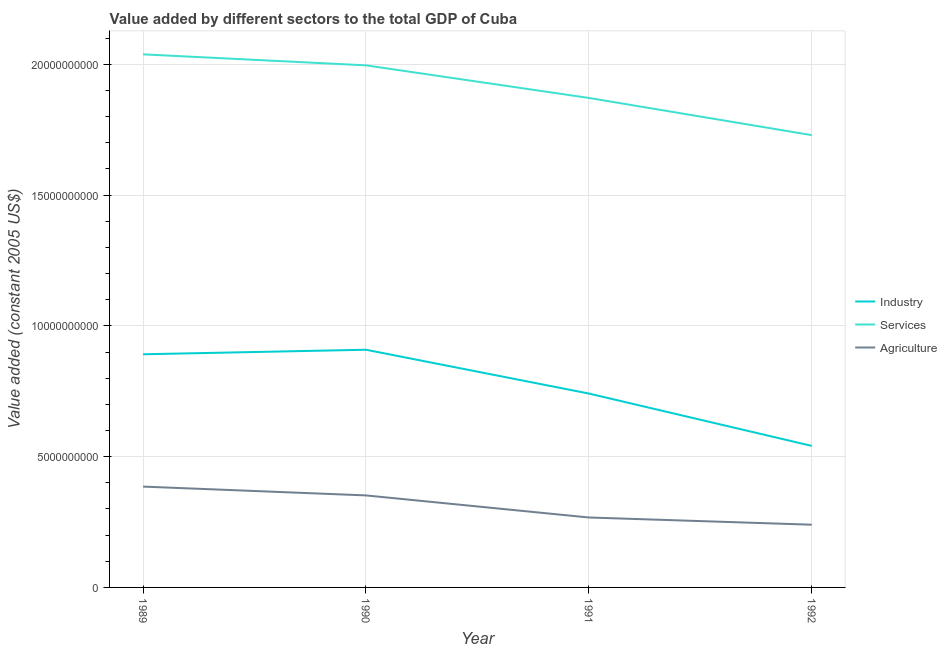What is the value added by agricultural sector in 1992?
Offer a very short reply. 2.40e+09. Across all years, what is the maximum value added by agricultural sector?
Your answer should be compact. 3.85e+09. Across all years, what is the minimum value added by agricultural sector?
Offer a very short reply. 2.40e+09. In which year was the value added by services maximum?
Ensure brevity in your answer.  1989. What is the total value added by agricultural sector in the graph?
Offer a terse response. 1.24e+1. What is the difference between the value added by industrial sector in 1991 and that in 1992?
Provide a short and direct response. 2.00e+09. What is the difference between the value added by industrial sector in 1992 and the value added by services in 1991?
Provide a succinct answer. -1.33e+1. What is the average value added by industrial sector per year?
Give a very brief answer. 7.71e+09. In the year 1991, what is the difference between the value added by services and value added by industrial sector?
Your response must be concise. 1.13e+1. In how many years, is the value added by industrial sector greater than 1000000000 US$?
Give a very brief answer. 4. What is the ratio of the value added by agricultural sector in 1990 to that in 1992?
Provide a short and direct response. 1.47. Is the value added by services in 1989 less than that in 1990?
Ensure brevity in your answer.  No. Is the difference between the value added by services in 1990 and 1991 greater than the difference between the value added by industrial sector in 1990 and 1991?
Offer a terse response. No. What is the difference between the highest and the second highest value added by agricultural sector?
Your answer should be compact. 3.37e+08. What is the difference between the highest and the lowest value added by agricultural sector?
Your answer should be compact. 1.46e+09. Is the sum of the value added by agricultural sector in 1991 and 1992 greater than the maximum value added by industrial sector across all years?
Provide a short and direct response. No. Does the value added by services monotonically increase over the years?
Your answer should be very brief. No. Is the value added by industrial sector strictly less than the value added by agricultural sector over the years?
Offer a terse response. No. What is the difference between two consecutive major ticks on the Y-axis?
Offer a terse response. 5.00e+09. Does the graph contain grids?
Make the answer very short. Yes. Where does the legend appear in the graph?
Make the answer very short. Center right. How many legend labels are there?
Provide a short and direct response. 3. How are the legend labels stacked?
Provide a short and direct response. Vertical. What is the title of the graph?
Give a very brief answer. Value added by different sectors to the total GDP of Cuba. Does "Food" appear as one of the legend labels in the graph?
Ensure brevity in your answer.  No. What is the label or title of the Y-axis?
Provide a succinct answer. Value added (constant 2005 US$). What is the Value added (constant 2005 US$) in Industry in 1989?
Your answer should be compact. 8.91e+09. What is the Value added (constant 2005 US$) of Services in 1989?
Your answer should be compact. 2.04e+1. What is the Value added (constant 2005 US$) in Agriculture in 1989?
Provide a succinct answer. 3.85e+09. What is the Value added (constant 2005 US$) in Industry in 1990?
Give a very brief answer. 9.09e+09. What is the Value added (constant 2005 US$) in Services in 1990?
Keep it short and to the point. 2.00e+1. What is the Value added (constant 2005 US$) of Agriculture in 1990?
Make the answer very short. 3.52e+09. What is the Value added (constant 2005 US$) of Industry in 1991?
Ensure brevity in your answer.  7.41e+09. What is the Value added (constant 2005 US$) of Services in 1991?
Make the answer very short. 1.87e+1. What is the Value added (constant 2005 US$) of Agriculture in 1991?
Your response must be concise. 2.67e+09. What is the Value added (constant 2005 US$) in Industry in 1992?
Your answer should be very brief. 5.41e+09. What is the Value added (constant 2005 US$) of Services in 1992?
Give a very brief answer. 1.73e+1. What is the Value added (constant 2005 US$) in Agriculture in 1992?
Ensure brevity in your answer.  2.40e+09. Across all years, what is the maximum Value added (constant 2005 US$) in Industry?
Give a very brief answer. 9.09e+09. Across all years, what is the maximum Value added (constant 2005 US$) of Services?
Offer a very short reply. 2.04e+1. Across all years, what is the maximum Value added (constant 2005 US$) of Agriculture?
Your answer should be very brief. 3.85e+09. Across all years, what is the minimum Value added (constant 2005 US$) of Industry?
Offer a very short reply. 5.41e+09. Across all years, what is the minimum Value added (constant 2005 US$) in Services?
Give a very brief answer. 1.73e+1. Across all years, what is the minimum Value added (constant 2005 US$) of Agriculture?
Ensure brevity in your answer.  2.40e+09. What is the total Value added (constant 2005 US$) of Industry in the graph?
Your response must be concise. 3.08e+1. What is the total Value added (constant 2005 US$) of Services in the graph?
Make the answer very short. 7.63e+1. What is the total Value added (constant 2005 US$) of Agriculture in the graph?
Your answer should be compact. 1.24e+1. What is the difference between the Value added (constant 2005 US$) of Industry in 1989 and that in 1990?
Keep it short and to the point. -1.73e+08. What is the difference between the Value added (constant 2005 US$) of Services in 1989 and that in 1990?
Keep it short and to the point. 4.21e+08. What is the difference between the Value added (constant 2005 US$) of Agriculture in 1989 and that in 1990?
Make the answer very short. 3.37e+08. What is the difference between the Value added (constant 2005 US$) in Industry in 1989 and that in 1991?
Your response must be concise. 1.50e+09. What is the difference between the Value added (constant 2005 US$) of Services in 1989 and that in 1991?
Provide a succinct answer. 1.67e+09. What is the difference between the Value added (constant 2005 US$) of Agriculture in 1989 and that in 1991?
Offer a terse response. 1.18e+09. What is the difference between the Value added (constant 2005 US$) of Industry in 1989 and that in 1992?
Make the answer very short. 3.50e+09. What is the difference between the Value added (constant 2005 US$) in Services in 1989 and that in 1992?
Provide a succinct answer. 3.09e+09. What is the difference between the Value added (constant 2005 US$) of Agriculture in 1989 and that in 1992?
Provide a short and direct response. 1.46e+09. What is the difference between the Value added (constant 2005 US$) of Industry in 1990 and that in 1991?
Your answer should be very brief. 1.67e+09. What is the difference between the Value added (constant 2005 US$) of Services in 1990 and that in 1991?
Provide a short and direct response. 1.25e+09. What is the difference between the Value added (constant 2005 US$) of Agriculture in 1990 and that in 1991?
Provide a short and direct response. 8.44e+08. What is the difference between the Value added (constant 2005 US$) in Industry in 1990 and that in 1992?
Give a very brief answer. 3.68e+09. What is the difference between the Value added (constant 2005 US$) in Services in 1990 and that in 1992?
Ensure brevity in your answer.  2.67e+09. What is the difference between the Value added (constant 2005 US$) in Agriculture in 1990 and that in 1992?
Your answer should be very brief. 1.12e+09. What is the difference between the Value added (constant 2005 US$) in Industry in 1991 and that in 1992?
Provide a short and direct response. 2.00e+09. What is the difference between the Value added (constant 2005 US$) of Services in 1991 and that in 1992?
Make the answer very short. 1.42e+09. What is the difference between the Value added (constant 2005 US$) in Agriculture in 1991 and that in 1992?
Provide a succinct answer. 2.76e+08. What is the difference between the Value added (constant 2005 US$) in Industry in 1989 and the Value added (constant 2005 US$) in Services in 1990?
Ensure brevity in your answer.  -1.10e+1. What is the difference between the Value added (constant 2005 US$) in Industry in 1989 and the Value added (constant 2005 US$) in Agriculture in 1990?
Ensure brevity in your answer.  5.40e+09. What is the difference between the Value added (constant 2005 US$) in Services in 1989 and the Value added (constant 2005 US$) in Agriculture in 1990?
Give a very brief answer. 1.69e+1. What is the difference between the Value added (constant 2005 US$) in Industry in 1989 and the Value added (constant 2005 US$) in Services in 1991?
Keep it short and to the point. -9.80e+09. What is the difference between the Value added (constant 2005 US$) of Industry in 1989 and the Value added (constant 2005 US$) of Agriculture in 1991?
Offer a very short reply. 6.24e+09. What is the difference between the Value added (constant 2005 US$) of Services in 1989 and the Value added (constant 2005 US$) of Agriculture in 1991?
Offer a terse response. 1.77e+1. What is the difference between the Value added (constant 2005 US$) of Industry in 1989 and the Value added (constant 2005 US$) of Services in 1992?
Your answer should be compact. -8.38e+09. What is the difference between the Value added (constant 2005 US$) in Industry in 1989 and the Value added (constant 2005 US$) in Agriculture in 1992?
Your answer should be very brief. 6.52e+09. What is the difference between the Value added (constant 2005 US$) of Services in 1989 and the Value added (constant 2005 US$) of Agriculture in 1992?
Keep it short and to the point. 1.80e+1. What is the difference between the Value added (constant 2005 US$) in Industry in 1990 and the Value added (constant 2005 US$) in Services in 1991?
Offer a very short reply. -9.63e+09. What is the difference between the Value added (constant 2005 US$) of Industry in 1990 and the Value added (constant 2005 US$) of Agriculture in 1991?
Keep it short and to the point. 6.41e+09. What is the difference between the Value added (constant 2005 US$) in Services in 1990 and the Value added (constant 2005 US$) in Agriculture in 1991?
Provide a succinct answer. 1.73e+1. What is the difference between the Value added (constant 2005 US$) in Industry in 1990 and the Value added (constant 2005 US$) in Services in 1992?
Provide a short and direct response. -8.20e+09. What is the difference between the Value added (constant 2005 US$) of Industry in 1990 and the Value added (constant 2005 US$) of Agriculture in 1992?
Your answer should be very brief. 6.69e+09. What is the difference between the Value added (constant 2005 US$) in Services in 1990 and the Value added (constant 2005 US$) in Agriculture in 1992?
Your answer should be compact. 1.76e+1. What is the difference between the Value added (constant 2005 US$) in Industry in 1991 and the Value added (constant 2005 US$) in Services in 1992?
Provide a succinct answer. -9.88e+09. What is the difference between the Value added (constant 2005 US$) of Industry in 1991 and the Value added (constant 2005 US$) of Agriculture in 1992?
Provide a short and direct response. 5.01e+09. What is the difference between the Value added (constant 2005 US$) in Services in 1991 and the Value added (constant 2005 US$) in Agriculture in 1992?
Your answer should be very brief. 1.63e+1. What is the average Value added (constant 2005 US$) in Industry per year?
Provide a short and direct response. 7.71e+09. What is the average Value added (constant 2005 US$) in Services per year?
Make the answer very short. 1.91e+1. What is the average Value added (constant 2005 US$) in Agriculture per year?
Ensure brevity in your answer.  3.11e+09. In the year 1989, what is the difference between the Value added (constant 2005 US$) of Industry and Value added (constant 2005 US$) of Services?
Keep it short and to the point. -1.15e+1. In the year 1989, what is the difference between the Value added (constant 2005 US$) in Industry and Value added (constant 2005 US$) in Agriculture?
Provide a short and direct response. 5.06e+09. In the year 1989, what is the difference between the Value added (constant 2005 US$) of Services and Value added (constant 2005 US$) of Agriculture?
Your answer should be very brief. 1.65e+1. In the year 1990, what is the difference between the Value added (constant 2005 US$) of Industry and Value added (constant 2005 US$) of Services?
Make the answer very short. -1.09e+1. In the year 1990, what is the difference between the Value added (constant 2005 US$) of Industry and Value added (constant 2005 US$) of Agriculture?
Keep it short and to the point. 5.57e+09. In the year 1990, what is the difference between the Value added (constant 2005 US$) of Services and Value added (constant 2005 US$) of Agriculture?
Offer a very short reply. 1.64e+1. In the year 1991, what is the difference between the Value added (constant 2005 US$) in Industry and Value added (constant 2005 US$) in Services?
Your answer should be compact. -1.13e+1. In the year 1991, what is the difference between the Value added (constant 2005 US$) in Industry and Value added (constant 2005 US$) in Agriculture?
Your answer should be compact. 4.74e+09. In the year 1991, what is the difference between the Value added (constant 2005 US$) in Services and Value added (constant 2005 US$) in Agriculture?
Keep it short and to the point. 1.60e+1. In the year 1992, what is the difference between the Value added (constant 2005 US$) of Industry and Value added (constant 2005 US$) of Services?
Ensure brevity in your answer.  -1.19e+1. In the year 1992, what is the difference between the Value added (constant 2005 US$) in Industry and Value added (constant 2005 US$) in Agriculture?
Give a very brief answer. 3.01e+09. In the year 1992, what is the difference between the Value added (constant 2005 US$) of Services and Value added (constant 2005 US$) of Agriculture?
Give a very brief answer. 1.49e+1. What is the ratio of the Value added (constant 2005 US$) of Industry in 1989 to that in 1990?
Make the answer very short. 0.98. What is the ratio of the Value added (constant 2005 US$) of Services in 1989 to that in 1990?
Ensure brevity in your answer.  1.02. What is the ratio of the Value added (constant 2005 US$) of Agriculture in 1989 to that in 1990?
Your answer should be very brief. 1.1. What is the ratio of the Value added (constant 2005 US$) in Industry in 1989 to that in 1991?
Make the answer very short. 1.2. What is the ratio of the Value added (constant 2005 US$) of Services in 1989 to that in 1991?
Provide a short and direct response. 1.09. What is the ratio of the Value added (constant 2005 US$) in Agriculture in 1989 to that in 1991?
Provide a succinct answer. 1.44. What is the ratio of the Value added (constant 2005 US$) of Industry in 1989 to that in 1992?
Provide a succinct answer. 1.65. What is the ratio of the Value added (constant 2005 US$) in Services in 1989 to that in 1992?
Your response must be concise. 1.18. What is the ratio of the Value added (constant 2005 US$) in Agriculture in 1989 to that in 1992?
Your answer should be very brief. 1.61. What is the ratio of the Value added (constant 2005 US$) in Industry in 1990 to that in 1991?
Provide a short and direct response. 1.23. What is the ratio of the Value added (constant 2005 US$) in Services in 1990 to that in 1991?
Your response must be concise. 1.07. What is the ratio of the Value added (constant 2005 US$) of Agriculture in 1990 to that in 1991?
Keep it short and to the point. 1.32. What is the ratio of the Value added (constant 2005 US$) of Industry in 1990 to that in 1992?
Make the answer very short. 1.68. What is the ratio of the Value added (constant 2005 US$) in Services in 1990 to that in 1992?
Provide a short and direct response. 1.15. What is the ratio of the Value added (constant 2005 US$) of Agriculture in 1990 to that in 1992?
Offer a very short reply. 1.47. What is the ratio of the Value added (constant 2005 US$) in Industry in 1991 to that in 1992?
Ensure brevity in your answer.  1.37. What is the ratio of the Value added (constant 2005 US$) in Services in 1991 to that in 1992?
Offer a very short reply. 1.08. What is the ratio of the Value added (constant 2005 US$) of Agriculture in 1991 to that in 1992?
Make the answer very short. 1.12. What is the difference between the highest and the second highest Value added (constant 2005 US$) of Industry?
Give a very brief answer. 1.73e+08. What is the difference between the highest and the second highest Value added (constant 2005 US$) of Services?
Your answer should be compact. 4.21e+08. What is the difference between the highest and the second highest Value added (constant 2005 US$) in Agriculture?
Your answer should be very brief. 3.37e+08. What is the difference between the highest and the lowest Value added (constant 2005 US$) in Industry?
Provide a short and direct response. 3.68e+09. What is the difference between the highest and the lowest Value added (constant 2005 US$) of Services?
Give a very brief answer. 3.09e+09. What is the difference between the highest and the lowest Value added (constant 2005 US$) of Agriculture?
Offer a terse response. 1.46e+09. 